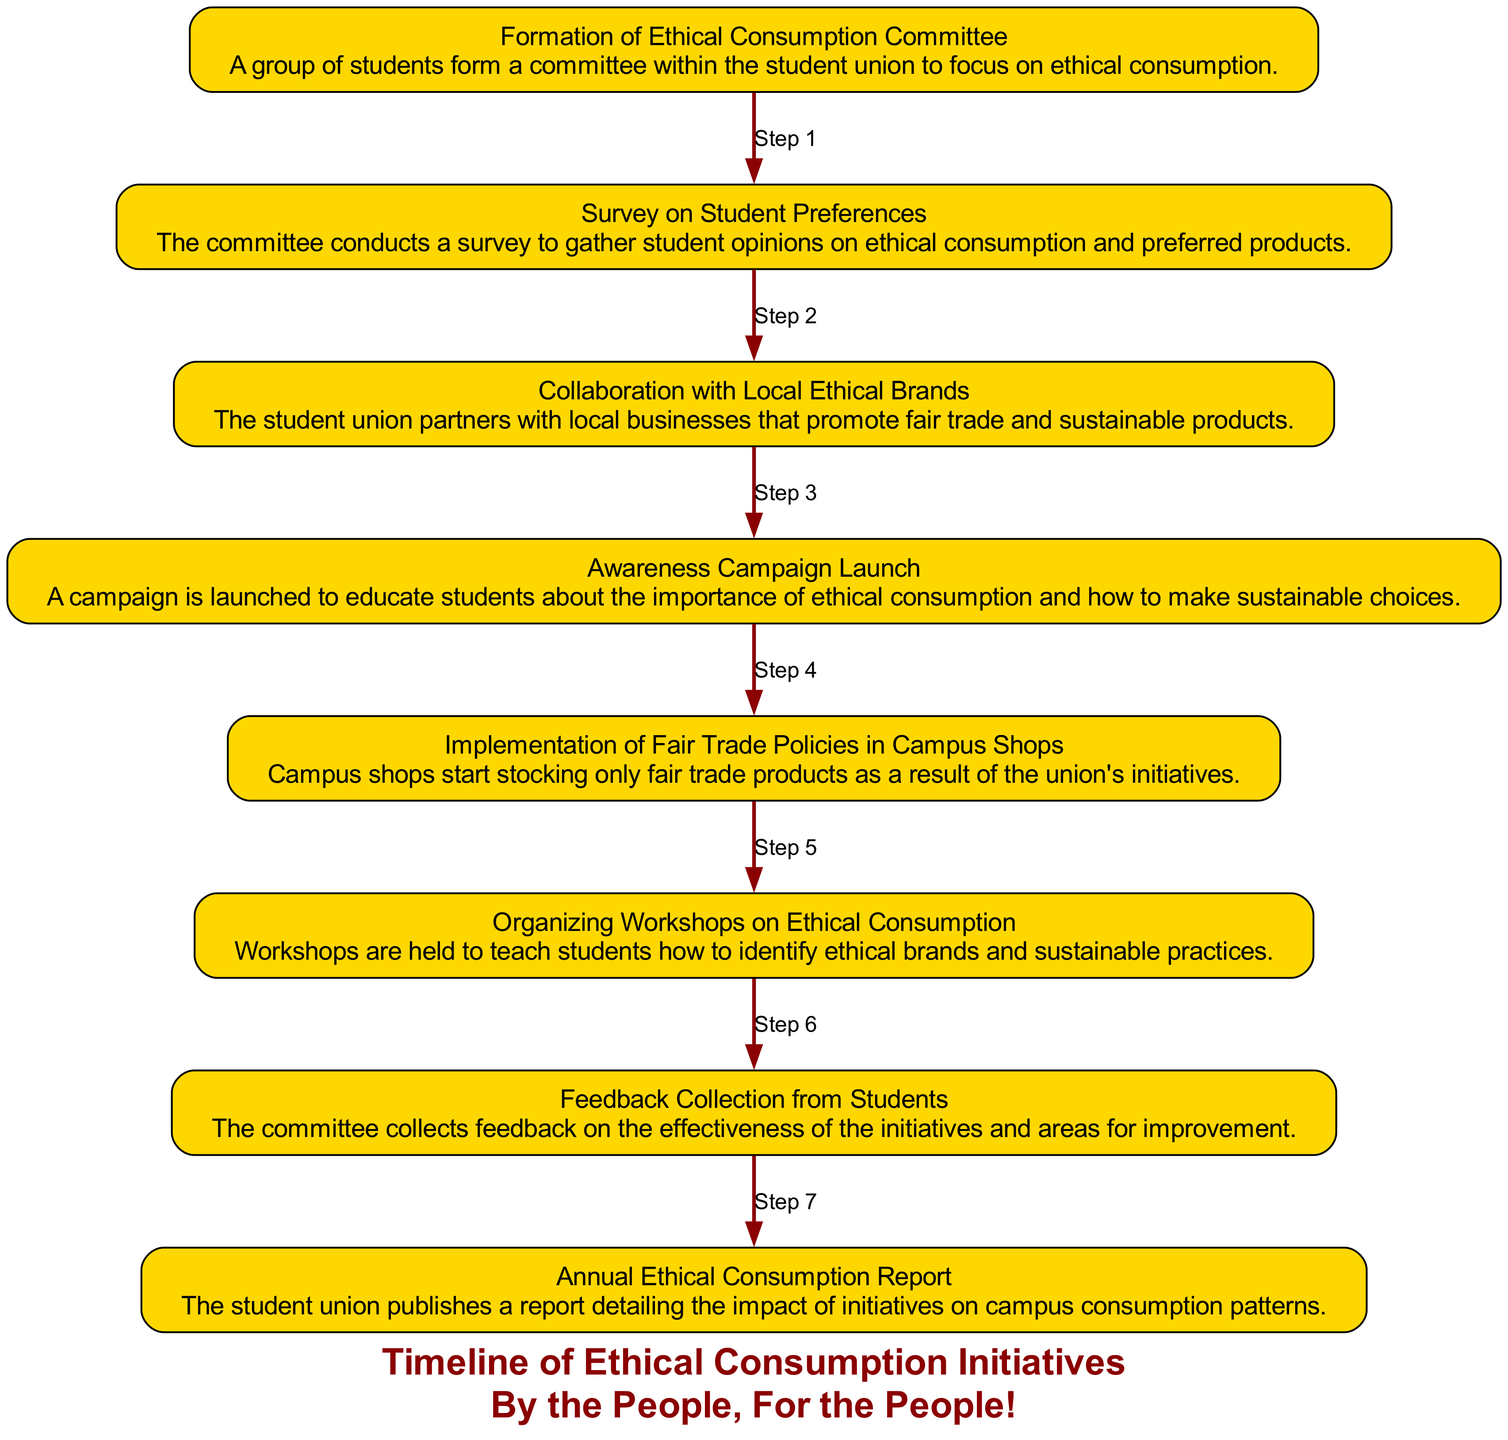What is the first event listed in the timeline? The first event is "Formation of Ethical Consumption Committee," which is the initial step in the sequence of initiatives taken by the student union.
Answer: Formation of Ethical Consumption Committee How many total events are documented in the timeline? By counting the listed events in the diagram, there are a total of eight distinct events in the sequence.
Answer: Eight What follows after the Awareness Campaign Launch? The next event that follows after the "Awareness Campaign Launch" is the "Implementation of Fair Trade Policies in Campus Shops." This is sequentially indicated in the diagram.
Answer: Implementation of Fair Trade Policies in Campus Shops Which event includes feedback collection? The event that includes feedback collection is titled "Feedback Collection from Students." This is identified as a specific node in the timeline.
Answer: Feedback Collection from Students What is the outcome reported in the final event? The final event reports on the overall impact of the initiatives in the "Annual Ethical Consumption Report," summarizing the effects on campus consumption patterns.
Answer: Annual Ethical Consumption Report Which two events are linked by ‘Step 1’? The events connected by 'Step 1' are "Formation of Ethical Consumption Committee" and "Survey on Student Preferences," indicating the logical flow between these two activities.
Answer: Formation of Ethical Consumption Committee and Survey on Student Preferences What kind of partnerships does the student union engage in as part of their initiatives? The student union collaborates with "Local Ethical Brands" as part of its initiative to promote ethical consumption, demonstrating community engagement.
Answer: Local Ethical Brands What educational activity is organized according to the sequence? The sequence includes an educational activity titled "Organizing Workshops on Ethical Consumption," aimed at teaching students about ethical brands and sustainable practices.
Answer: Organizing Workshops on Ethical Consumption 